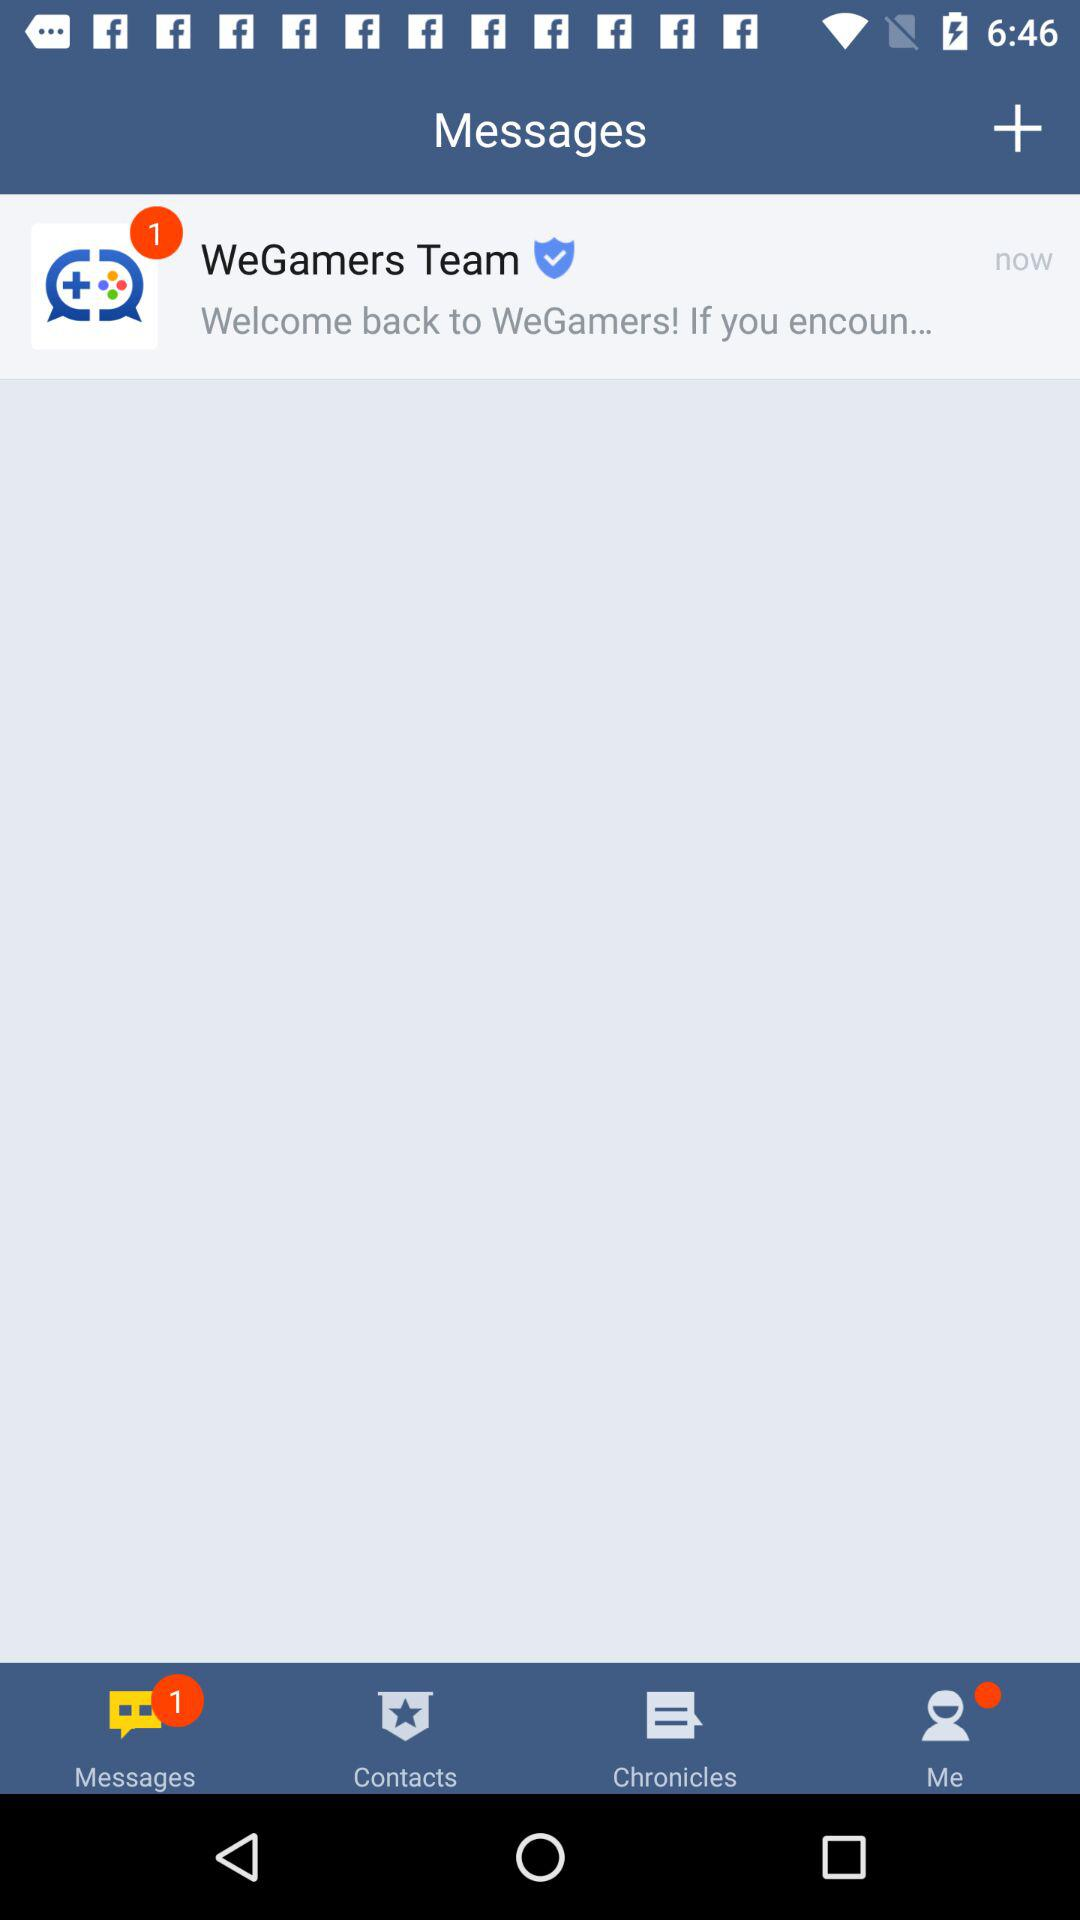What is the number of notifications in "WeGamers Team"? The number of notifications is 1. 